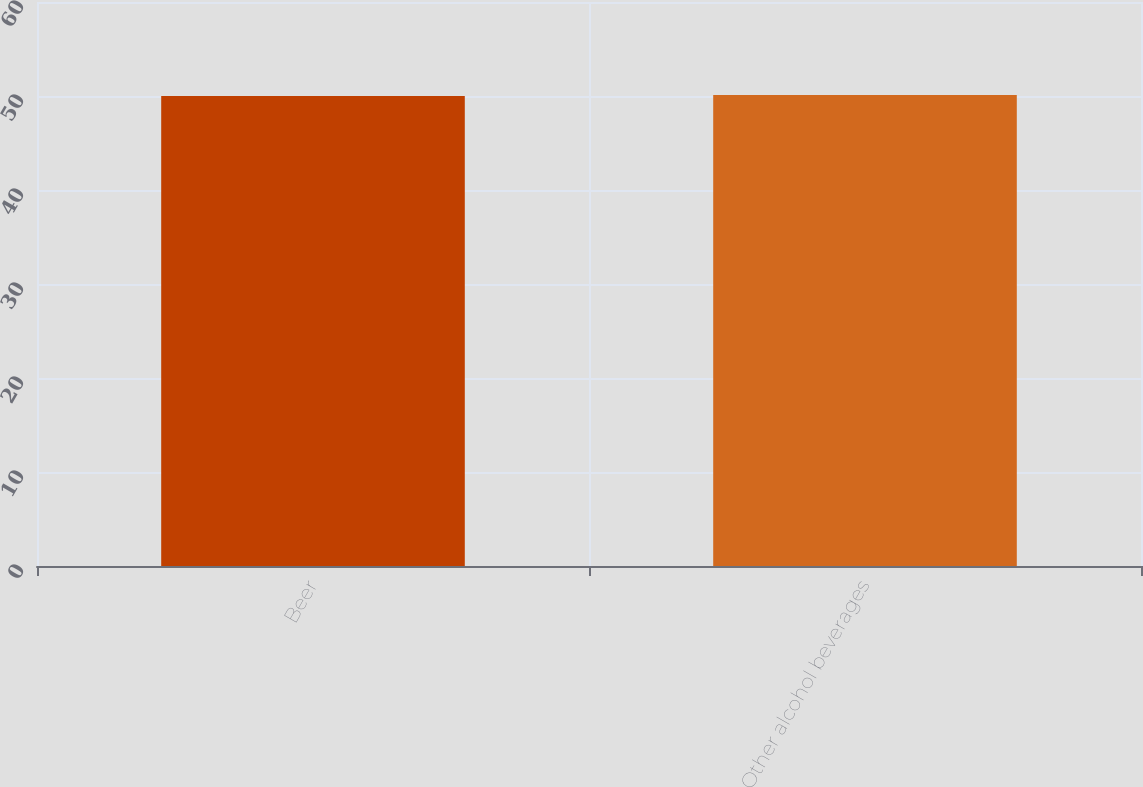Convert chart. <chart><loc_0><loc_0><loc_500><loc_500><bar_chart><fcel>Beer<fcel>Other alcohol beverages<nl><fcel>50<fcel>50.1<nl></chart> 